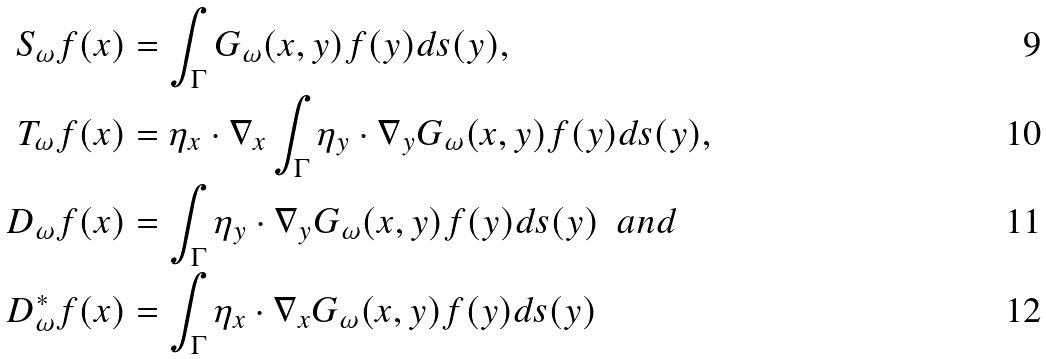Convert formula to latex. <formula><loc_0><loc_0><loc_500><loc_500>S _ { \omega } f ( x ) & = \int _ { \Gamma } G _ { \omega } ( x , y ) f ( y ) d s ( y ) , \\ T _ { \omega } f ( x ) & = \eta _ { x } \cdot \nabla _ { x } \int _ { \Gamma } \eta _ { y } \cdot \nabla _ { y } G _ { \omega } ( x , y ) f ( y ) d s ( y ) , \\ D _ { \omega } f ( x ) & = \int _ { \Gamma } \eta _ { y } \cdot \nabla _ { y } G _ { \omega } ( x , y ) f ( y ) d s ( y ) \ \ a n d \\ D _ { \omega } ^ { * } f ( x ) & = \int _ { \Gamma } \eta _ { x } \cdot \nabla _ { x } G _ { \omega } ( x , y ) f ( y ) d s ( y )</formula> 